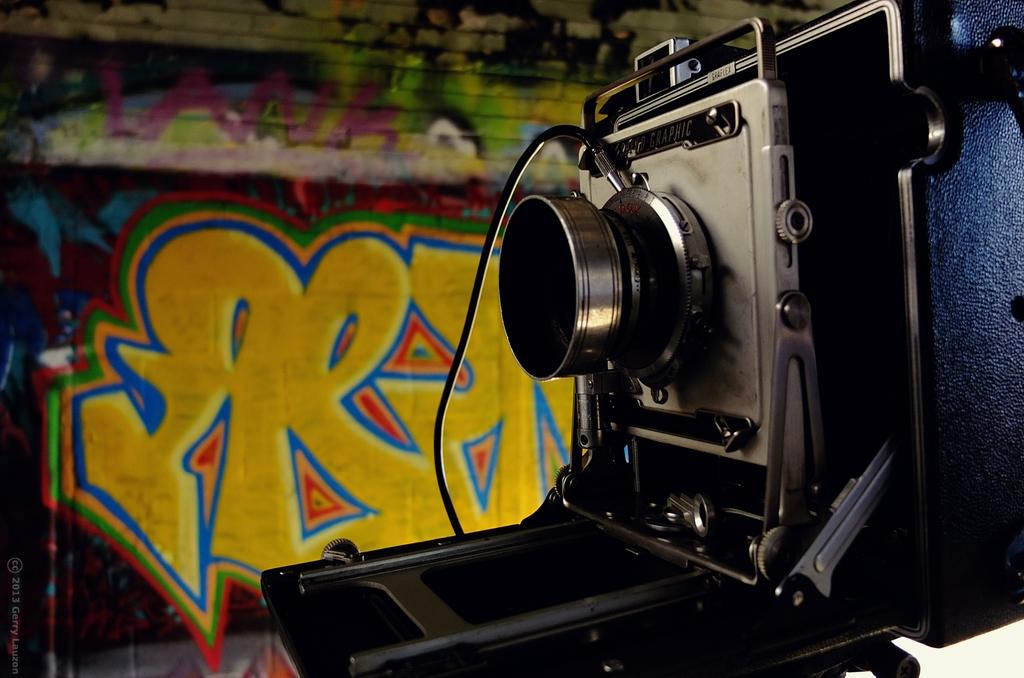What is the main subject in the center of the image? There is a camera in the center of the image. What can be seen in the background of the image? There is a painting on the wall in the background of the image. What type of balloon is being used to design the camera in the image? There is no balloon present in the image, and the camera is not being designed in the image. 